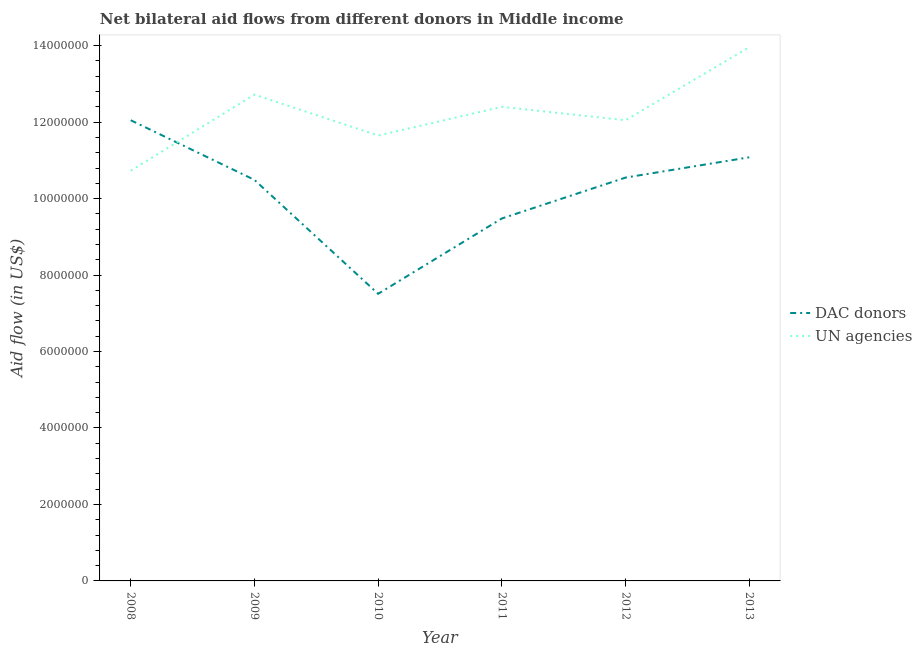What is the aid flow from un agencies in 2013?
Your response must be concise. 1.40e+07. Across all years, what is the maximum aid flow from dac donors?
Provide a succinct answer. 1.20e+07. Across all years, what is the minimum aid flow from un agencies?
Provide a succinct answer. 1.07e+07. What is the total aid flow from dac donors in the graph?
Your response must be concise. 6.12e+07. What is the difference between the aid flow from dac donors in 2011 and that in 2013?
Offer a very short reply. -1.60e+06. What is the difference between the aid flow from dac donors in 2012 and the aid flow from un agencies in 2010?
Offer a very short reply. -1.10e+06. What is the average aid flow from dac donors per year?
Keep it short and to the point. 1.02e+07. In the year 2013, what is the difference between the aid flow from dac donors and aid flow from un agencies?
Your answer should be compact. -2.88e+06. In how many years, is the aid flow from un agencies greater than 6800000 US$?
Your answer should be very brief. 6. What is the ratio of the aid flow from un agencies in 2011 to that in 2013?
Provide a short and direct response. 0.89. Is the difference between the aid flow from un agencies in 2012 and 2013 greater than the difference between the aid flow from dac donors in 2012 and 2013?
Your response must be concise. No. What is the difference between the highest and the second highest aid flow from un agencies?
Your response must be concise. 1.24e+06. What is the difference between the highest and the lowest aid flow from un agencies?
Keep it short and to the point. 3.23e+06. In how many years, is the aid flow from dac donors greater than the average aid flow from dac donors taken over all years?
Keep it short and to the point. 4. Is the sum of the aid flow from dac donors in 2009 and 2011 greater than the maximum aid flow from un agencies across all years?
Give a very brief answer. Yes. Is the aid flow from dac donors strictly greater than the aid flow from un agencies over the years?
Your answer should be compact. No. Is the aid flow from dac donors strictly less than the aid flow from un agencies over the years?
Your answer should be very brief. No. How many lines are there?
Offer a very short reply. 2. How many years are there in the graph?
Make the answer very short. 6. Does the graph contain any zero values?
Your answer should be compact. No. Does the graph contain grids?
Provide a succinct answer. No. How many legend labels are there?
Offer a terse response. 2. How are the legend labels stacked?
Offer a terse response. Vertical. What is the title of the graph?
Give a very brief answer. Net bilateral aid flows from different donors in Middle income. Does "Netherlands" appear as one of the legend labels in the graph?
Keep it short and to the point. No. What is the label or title of the X-axis?
Give a very brief answer. Year. What is the label or title of the Y-axis?
Give a very brief answer. Aid flow (in US$). What is the Aid flow (in US$) of DAC donors in 2008?
Offer a very short reply. 1.20e+07. What is the Aid flow (in US$) in UN agencies in 2008?
Make the answer very short. 1.07e+07. What is the Aid flow (in US$) of DAC donors in 2009?
Offer a very short reply. 1.05e+07. What is the Aid flow (in US$) in UN agencies in 2009?
Make the answer very short. 1.27e+07. What is the Aid flow (in US$) in DAC donors in 2010?
Keep it short and to the point. 7.51e+06. What is the Aid flow (in US$) in UN agencies in 2010?
Offer a terse response. 1.16e+07. What is the Aid flow (in US$) of DAC donors in 2011?
Keep it short and to the point. 9.48e+06. What is the Aid flow (in US$) of UN agencies in 2011?
Give a very brief answer. 1.24e+07. What is the Aid flow (in US$) in DAC donors in 2012?
Give a very brief answer. 1.06e+07. What is the Aid flow (in US$) of UN agencies in 2012?
Ensure brevity in your answer.  1.20e+07. What is the Aid flow (in US$) of DAC donors in 2013?
Give a very brief answer. 1.11e+07. What is the Aid flow (in US$) in UN agencies in 2013?
Your response must be concise. 1.40e+07. Across all years, what is the maximum Aid flow (in US$) of DAC donors?
Your answer should be compact. 1.20e+07. Across all years, what is the maximum Aid flow (in US$) in UN agencies?
Your answer should be very brief. 1.40e+07. Across all years, what is the minimum Aid flow (in US$) in DAC donors?
Your response must be concise. 7.51e+06. Across all years, what is the minimum Aid flow (in US$) in UN agencies?
Ensure brevity in your answer.  1.07e+07. What is the total Aid flow (in US$) of DAC donors in the graph?
Keep it short and to the point. 6.12e+07. What is the total Aid flow (in US$) of UN agencies in the graph?
Your answer should be compact. 7.35e+07. What is the difference between the Aid flow (in US$) in DAC donors in 2008 and that in 2009?
Give a very brief answer. 1.56e+06. What is the difference between the Aid flow (in US$) of UN agencies in 2008 and that in 2009?
Your answer should be compact. -1.99e+06. What is the difference between the Aid flow (in US$) of DAC donors in 2008 and that in 2010?
Ensure brevity in your answer.  4.54e+06. What is the difference between the Aid flow (in US$) in UN agencies in 2008 and that in 2010?
Your answer should be compact. -9.20e+05. What is the difference between the Aid flow (in US$) of DAC donors in 2008 and that in 2011?
Provide a succinct answer. 2.57e+06. What is the difference between the Aid flow (in US$) in UN agencies in 2008 and that in 2011?
Give a very brief answer. -1.67e+06. What is the difference between the Aid flow (in US$) of DAC donors in 2008 and that in 2012?
Keep it short and to the point. 1.50e+06. What is the difference between the Aid flow (in US$) in UN agencies in 2008 and that in 2012?
Ensure brevity in your answer.  -1.32e+06. What is the difference between the Aid flow (in US$) of DAC donors in 2008 and that in 2013?
Keep it short and to the point. 9.70e+05. What is the difference between the Aid flow (in US$) in UN agencies in 2008 and that in 2013?
Offer a very short reply. -3.23e+06. What is the difference between the Aid flow (in US$) of DAC donors in 2009 and that in 2010?
Your answer should be very brief. 2.98e+06. What is the difference between the Aid flow (in US$) of UN agencies in 2009 and that in 2010?
Your answer should be compact. 1.07e+06. What is the difference between the Aid flow (in US$) of DAC donors in 2009 and that in 2011?
Ensure brevity in your answer.  1.01e+06. What is the difference between the Aid flow (in US$) in DAC donors in 2009 and that in 2012?
Offer a terse response. -6.00e+04. What is the difference between the Aid flow (in US$) in UN agencies in 2009 and that in 2012?
Your answer should be very brief. 6.70e+05. What is the difference between the Aid flow (in US$) in DAC donors in 2009 and that in 2013?
Your response must be concise. -5.90e+05. What is the difference between the Aid flow (in US$) of UN agencies in 2009 and that in 2013?
Offer a very short reply. -1.24e+06. What is the difference between the Aid flow (in US$) of DAC donors in 2010 and that in 2011?
Your answer should be compact. -1.97e+06. What is the difference between the Aid flow (in US$) of UN agencies in 2010 and that in 2011?
Keep it short and to the point. -7.50e+05. What is the difference between the Aid flow (in US$) of DAC donors in 2010 and that in 2012?
Your answer should be compact. -3.04e+06. What is the difference between the Aid flow (in US$) of UN agencies in 2010 and that in 2012?
Keep it short and to the point. -4.00e+05. What is the difference between the Aid flow (in US$) in DAC donors in 2010 and that in 2013?
Offer a terse response. -3.57e+06. What is the difference between the Aid flow (in US$) in UN agencies in 2010 and that in 2013?
Offer a very short reply. -2.31e+06. What is the difference between the Aid flow (in US$) in DAC donors in 2011 and that in 2012?
Provide a short and direct response. -1.07e+06. What is the difference between the Aid flow (in US$) of UN agencies in 2011 and that in 2012?
Your answer should be very brief. 3.50e+05. What is the difference between the Aid flow (in US$) of DAC donors in 2011 and that in 2013?
Your response must be concise. -1.60e+06. What is the difference between the Aid flow (in US$) in UN agencies in 2011 and that in 2013?
Ensure brevity in your answer.  -1.56e+06. What is the difference between the Aid flow (in US$) of DAC donors in 2012 and that in 2013?
Your answer should be compact. -5.30e+05. What is the difference between the Aid flow (in US$) in UN agencies in 2012 and that in 2013?
Your response must be concise. -1.91e+06. What is the difference between the Aid flow (in US$) of DAC donors in 2008 and the Aid flow (in US$) of UN agencies in 2009?
Provide a short and direct response. -6.70e+05. What is the difference between the Aid flow (in US$) in DAC donors in 2008 and the Aid flow (in US$) in UN agencies in 2011?
Keep it short and to the point. -3.50e+05. What is the difference between the Aid flow (in US$) of DAC donors in 2008 and the Aid flow (in US$) of UN agencies in 2013?
Keep it short and to the point. -1.91e+06. What is the difference between the Aid flow (in US$) of DAC donors in 2009 and the Aid flow (in US$) of UN agencies in 2010?
Your response must be concise. -1.16e+06. What is the difference between the Aid flow (in US$) in DAC donors in 2009 and the Aid flow (in US$) in UN agencies in 2011?
Ensure brevity in your answer.  -1.91e+06. What is the difference between the Aid flow (in US$) in DAC donors in 2009 and the Aid flow (in US$) in UN agencies in 2012?
Your response must be concise. -1.56e+06. What is the difference between the Aid flow (in US$) of DAC donors in 2009 and the Aid flow (in US$) of UN agencies in 2013?
Your response must be concise. -3.47e+06. What is the difference between the Aid flow (in US$) of DAC donors in 2010 and the Aid flow (in US$) of UN agencies in 2011?
Your answer should be very brief. -4.89e+06. What is the difference between the Aid flow (in US$) in DAC donors in 2010 and the Aid flow (in US$) in UN agencies in 2012?
Provide a short and direct response. -4.54e+06. What is the difference between the Aid flow (in US$) in DAC donors in 2010 and the Aid flow (in US$) in UN agencies in 2013?
Make the answer very short. -6.45e+06. What is the difference between the Aid flow (in US$) in DAC donors in 2011 and the Aid flow (in US$) in UN agencies in 2012?
Ensure brevity in your answer.  -2.57e+06. What is the difference between the Aid flow (in US$) in DAC donors in 2011 and the Aid flow (in US$) in UN agencies in 2013?
Your response must be concise. -4.48e+06. What is the difference between the Aid flow (in US$) of DAC donors in 2012 and the Aid flow (in US$) of UN agencies in 2013?
Give a very brief answer. -3.41e+06. What is the average Aid flow (in US$) in DAC donors per year?
Provide a succinct answer. 1.02e+07. What is the average Aid flow (in US$) of UN agencies per year?
Make the answer very short. 1.23e+07. In the year 2008, what is the difference between the Aid flow (in US$) in DAC donors and Aid flow (in US$) in UN agencies?
Provide a succinct answer. 1.32e+06. In the year 2009, what is the difference between the Aid flow (in US$) in DAC donors and Aid flow (in US$) in UN agencies?
Offer a terse response. -2.23e+06. In the year 2010, what is the difference between the Aid flow (in US$) of DAC donors and Aid flow (in US$) of UN agencies?
Your answer should be very brief. -4.14e+06. In the year 2011, what is the difference between the Aid flow (in US$) in DAC donors and Aid flow (in US$) in UN agencies?
Keep it short and to the point. -2.92e+06. In the year 2012, what is the difference between the Aid flow (in US$) of DAC donors and Aid flow (in US$) of UN agencies?
Your answer should be very brief. -1.50e+06. In the year 2013, what is the difference between the Aid flow (in US$) of DAC donors and Aid flow (in US$) of UN agencies?
Provide a short and direct response. -2.88e+06. What is the ratio of the Aid flow (in US$) of DAC donors in 2008 to that in 2009?
Make the answer very short. 1.15. What is the ratio of the Aid flow (in US$) of UN agencies in 2008 to that in 2009?
Make the answer very short. 0.84. What is the ratio of the Aid flow (in US$) in DAC donors in 2008 to that in 2010?
Your answer should be very brief. 1.6. What is the ratio of the Aid flow (in US$) of UN agencies in 2008 to that in 2010?
Provide a succinct answer. 0.92. What is the ratio of the Aid flow (in US$) in DAC donors in 2008 to that in 2011?
Provide a succinct answer. 1.27. What is the ratio of the Aid flow (in US$) of UN agencies in 2008 to that in 2011?
Offer a very short reply. 0.87. What is the ratio of the Aid flow (in US$) in DAC donors in 2008 to that in 2012?
Ensure brevity in your answer.  1.14. What is the ratio of the Aid flow (in US$) in UN agencies in 2008 to that in 2012?
Your response must be concise. 0.89. What is the ratio of the Aid flow (in US$) in DAC donors in 2008 to that in 2013?
Your response must be concise. 1.09. What is the ratio of the Aid flow (in US$) in UN agencies in 2008 to that in 2013?
Keep it short and to the point. 0.77. What is the ratio of the Aid flow (in US$) of DAC donors in 2009 to that in 2010?
Keep it short and to the point. 1.4. What is the ratio of the Aid flow (in US$) in UN agencies in 2009 to that in 2010?
Provide a short and direct response. 1.09. What is the ratio of the Aid flow (in US$) in DAC donors in 2009 to that in 2011?
Provide a short and direct response. 1.11. What is the ratio of the Aid flow (in US$) in UN agencies in 2009 to that in 2011?
Your answer should be compact. 1.03. What is the ratio of the Aid flow (in US$) of DAC donors in 2009 to that in 2012?
Make the answer very short. 0.99. What is the ratio of the Aid flow (in US$) in UN agencies in 2009 to that in 2012?
Give a very brief answer. 1.06. What is the ratio of the Aid flow (in US$) in DAC donors in 2009 to that in 2013?
Your answer should be very brief. 0.95. What is the ratio of the Aid flow (in US$) of UN agencies in 2009 to that in 2013?
Your answer should be compact. 0.91. What is the ratio of the Aid flow (in US$) in DAC donors in 2010 to that in 2011?
Offer a terse response. 0.79. What is the ratio of the Aid flow (in US$) in UN agencies in 2010 to that in 2011?
Your answer should be very brief. 0.94. What is the ratio of the Aid flow (in US$) in DAC donors in 2010 to that in 2012?
Make the answer very short. 0.71. What is the ratio of the Aid flow (in US$) in UN agencies in 2010 to that in 2012?
Give a very brief answer. 0.97. What is the ratio of the Aid flow (in US$) in DAC donors in 2010 to that in 2013?
Give a very brief answer. 0.68. What is the ratio of the Aid flow (in US$) in UN agencies in 2010 to that in 2013?
Your answer should be very brief. 0.83. What is the ratio of the Aid flow (in US$) of DAC donors in 2011 to that in 2012?
Make the answer very short. 0.9. What is the ratio of the Aid flow (in US$) in UN agencies in 2011 to that in 2012?
Make the answer very short. 1.03. What is the ratio of the Aid flow (in US$) of DAC donors in 2011 to that in 2013?
Your answer should be very brief. 0.86. What is the ratio of the Aid flow (in US$) in UN agencies in 2011 to that in 2013?
Give a very brief answer. 0.89. What is the ratio of the Aid flow (in US$) in DAC donors in 2012 to that in 2013?
Ensure brevity in your answer.  0.95. What is the ratio of the Aid flow (in US$) of UN agencies in 2012 to that in 2013?
Make the answer very short. 0.86. What is the difference between the highest and the second highest Aid flow (in US$) of DAC donors?
Ensure brevity in your answer.  9.70e+05. What is the difference between the highest and the second highest Aid flow (in US$) in UN agencies?
Provide a succinct answer. 1.24e+06. What is the difference between the highest and the lowest Aid flow (in US$) in DAC donors?
Your answer should be compact. 4.54e+06. What is the difference between the highest and the lowest Aid flow (in US$) in UN agencies?
Offer a terse response. 3.23e+06. 